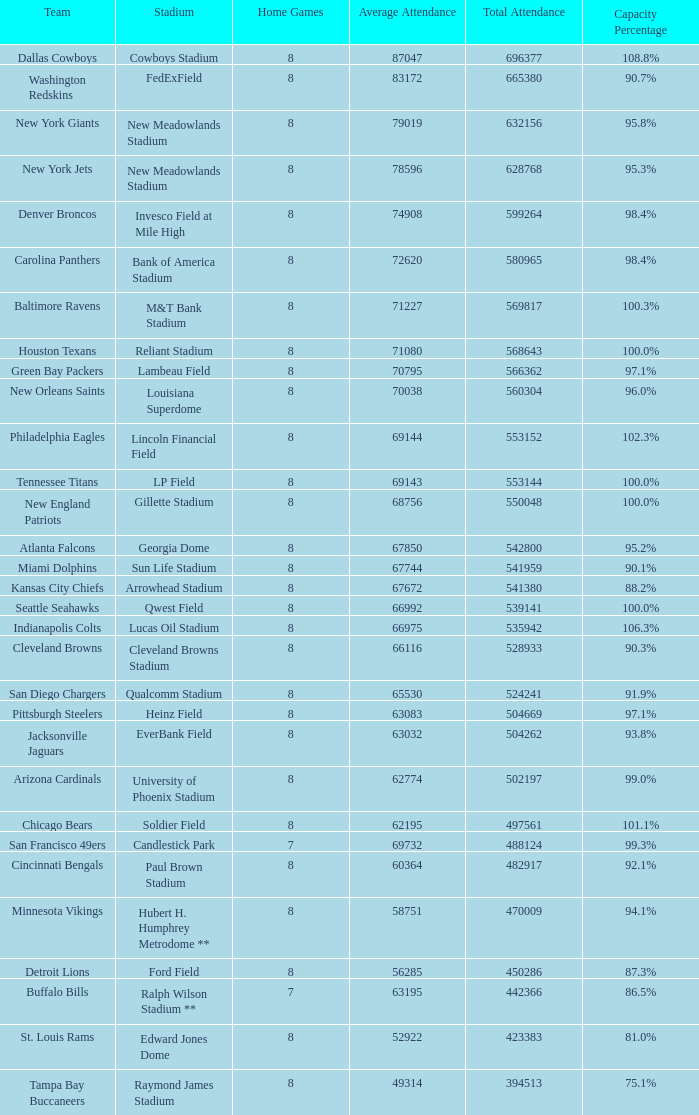What was the seating capacity for the denver broncos? 98.4%. 